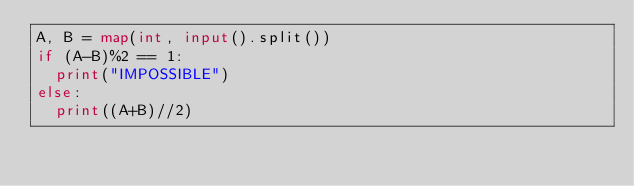<code> <loc_0><loc_0><loc_500><loc_500><_Python_>A, B = map(int, input().split())
if (A-B)%2 == 1:
  print("IMPOSSIBLE")
else:
  print((A+B)//2)</code> 